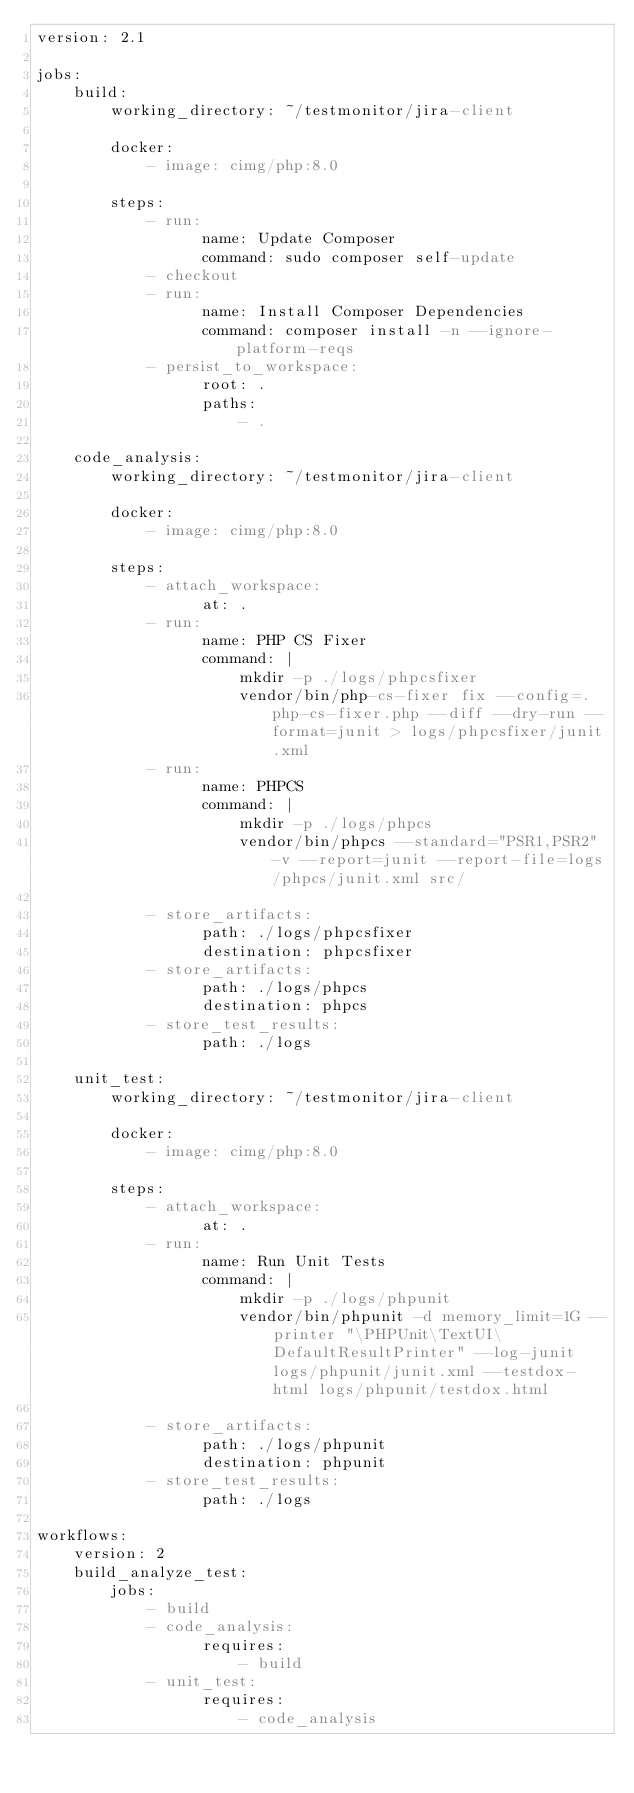Convert code to text. <code><loc_0><loc_0><loc_500><loc_500><_YAML_>version: 2.1

jobs:
    build:
        working_directory: ~/testmonitor/jira-client

        docker:
            - image: cimg/php:8.0

        steps:
            - run:
                  name: Update Composer
                  command: sudo composer self-update
            - checkout
            - run:
                  name: Install Composer Dependencies
                  command: composer install -n --ignore-platform-reqs
            - persist_to_workspace:
                  root: .
                  paths:
                      - .

    code_analysis:
        working_directory: ~/testmonitor/jira-client

        docker:
            - image: cimg/php:8.0

        steps:
            - attach_workspace:
                  at: .
            - run:
                  name: PHP CS Fixer
                  command: |
                      mkdir -p ./logs/phpcsfixer
                      vendor/bin/php-cs-fixer fix --config=.php-cs-fixer.php --diff --dry-run --format=junit > logs/phpcsfixer/junit.xml
            - run:
                  name: PHPCS
                  command: |
                      mkdir -p ./logs/phpcs
                      vendor/bin/phpcs --standard="PSR1,PSR2" -v --report=junit --report-file=logs/phpcs/junit.xml src/

            - store_artifacts:
                  path: ./logs/phpcsfixer
                  destination: phpcsfixer
            - store_artifacts:
                  path: ./logs/phpcs
                  destination: phpcs
            - store_test_results:
                  path: ./logs

    unit_test:
        working_directory: ~/testmonitor/jira-client

        docker:
            - image: cimg/php:8.0

        steps:
            - attach_workspace:
                  at: .
            - run:
                  name: Run Unit Tests
                  command: |
                      mkdir -p ./logs/phpunit
                      vendor/bin/phpunit -d memory_limit=1G --printer "\PHPUnit\TextUI\DefaultResultPrinter" --log-junit logs/phpunit/junit.xml --testdox-html logs/phpunit/testdox.html

            - store_artifacts:
                  path: ./logs/phpunit
                  destination: phpunit
            - store_test_results:
                  path: ./logs

workflows:
    version: 2
    build_analyze_test:
        jobs:
            - build
            - code_analysis:
                  requires:
                      - build
            - unit_test:
                  requires:
                      - code_analysis
</code> 